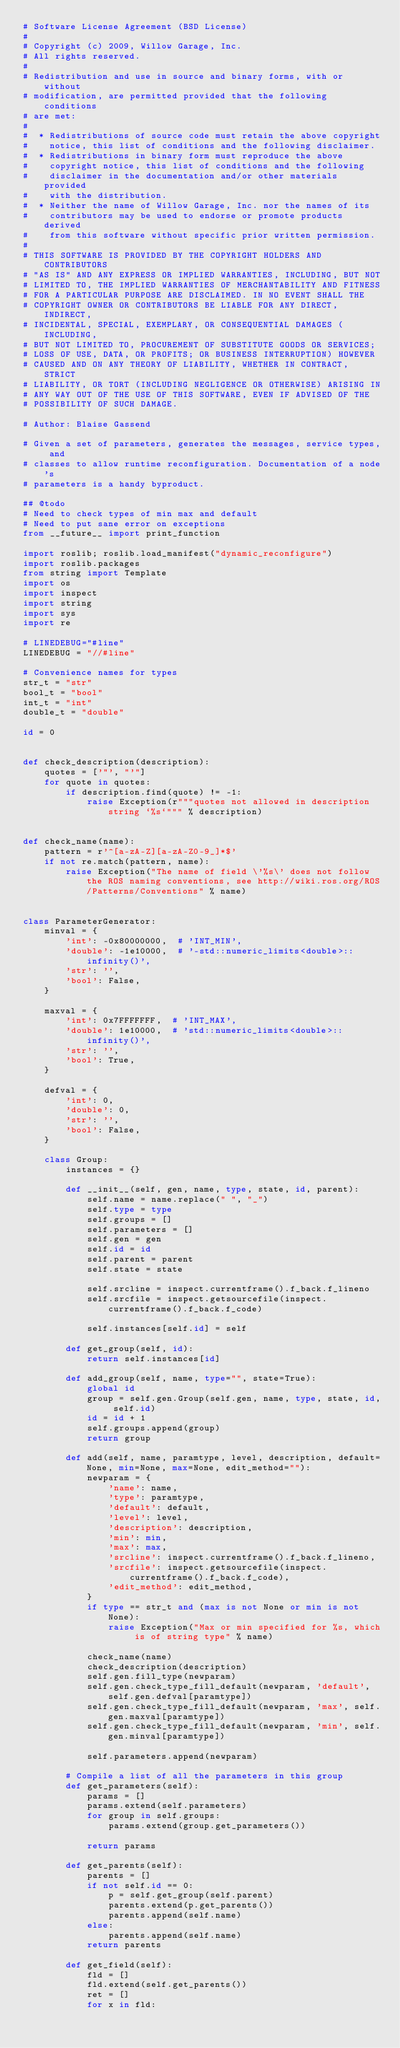<code> <loc_0><loc_0><loc_500><loc_500><_Python_># Software License Agreement (BSD License)
#
# Copyright (c) 2009, Willow Garage, Inc.
# All rights reserved.
#
# Redistribution and use in source and binary forms, with or without
# modification, are permitted provided that the following conditions
# are met:
#
#  * Redistributions of source code must retain the above copyright
#    notice, this list of conditions and the following disclaimer.
#  * Redistributions in binary form must reproduce the above
#    copyright notice, this list of conditions and the following
#    disclaimer in the documentation and/or other materials provided
#    with the distribution.
#  * Neither the name of Willow Garage, Inc. nor the names of its
#    contributors may be used to endorse or promote products derived
#    from this software without specific prior written permission.
#
# THIS SOFTWARE IS PROVIDED BY THE COPYRIGHT HOLDERS AND CONTRIBUTORS
# "AS IS" AND ANY EXPRESS OR IMPLIED WARRANTIES, INCLUDING, BUT NOT
# LIMITED TO, THE IMPLIED WARRANTIES OF MERCHANTABILITY AND FITNESS
# FOR A PARTICULAR PURPOSE ARE DISCLAIMED. IN NO EVENT SHALL THE
# COPYRIGHT OWNER OR CONTRIBUTORS BE LIABLE FOR ANY DIRECT, INDIRECT,
# INCIDENTAL, SPECIAL, EXEMPLARY, OR CONSEQUENTIAL DAMAGES (INCLUDING,
# BUT NOT LIMITED TO, PROCUREMENT OF SUBSTITUTE GOODS OR SERVICES;
# LOSS OF USE, DATA, OR PROFITS; OR BUSINESS INTERRUPTION) HOWEVER
# CAUSED AND ON ANY THEORY OF LIABILITY, WHETHER IN CONTRACT, STRICT
# LIABILITY, OR TORT (INCLUDING NEGLIGENCE OR OTHERWISE) ARISING IN
# ANY WAY OUT OF THE USE OF THIS SOFTWARE, EVEN IF ADVISED OF THE
# POSSIBILITY OF SUCH DAMAGE.

# Author: Blaise Gassend

# Given a set of parameters, generates the messages, service types, and
# classes to allow runtime reconfiguration. Documentation of a node's
# parameters is a handy byproduct.

## @todo
# Need to check types of min max and default
# Need to put sane error on exceptions
from __future__ import print_function

import roslib; roslib.load_manifest("dynamic_reconfigure")
import roslib.packages
from string import Template
import os
import inspect
import string
import sys
import re

# LINEDEBUG="#line"
LINEDEBUG = "//#line"

# Convenience names for types
str_t = "str"
bool_t = "bool"
int_t = "int"
double_t = "double"

id = 0


def check_description(description):
    quotes = ['"', "'"]
    for quote in quotes:
        if description.find(quote) != -1:
            raise Exception(r"""quotes not allowed in description string `%s`""" % description)


def check_name(name):
    pattern = r'^[a-zA-Z][a-zA-Z0-9_]*$'
    if not re.match(pattern, name):
        raise Exception("The name of field \'%s\' does not follow the ROS naming conventions, see http://wiki.ros.org/ROS/Patterns/Conventions" % name)


class ParameterGenerator:
    minval = {
        'int': -0x80000000,  # 'INT_MIN',
        'double': -1e10000,  # '-std::numeric_limits<double>::infinity()',
        'str': '',
        'bool': False,
    }

    maxval = {
        'int': 0x7FFFFFFF,  # 'INT_MAX',
        'double': 1e10000,  # 'std::numeric_limits<double>::infinity()',
        'str': '',
        'bool': True,
    }

    defval = {
        'int': 0,
        'double': 0,
        'str': '',
        'bool': False,
    }

    class Group:
        instances = {}

        def __init__(self, gen, name, type, state, id, parent):
            self.name = name.replace(" ", "_")
            self.type = type
            self.groups = []
            self.parameters = []
            self.gen = gen
            self.id = id
            self.parent = parent
            self.state = state

            self.srcline = inspect.currentframe().f_back.f_lineno
            self.srcfile = inspect.getsourcefile(inspect.currentframe().f_back.f_code)

            self.instances[self.id] = self

        def get_group(self, id):
            return self.instances[id]

        def add_group(self, name, type="", state=True):
            global id
            group = self.gen.Group(self.gen, name, type, state, id, self.id)
            id = id + 1
            self.groups.append(group)
            return group

        def add(self, name, paramtype, level, description, default=None, min=None, max=None, edit_method=""):
            newparam = {
                'name': name,
                'type': paramtype,
                'default': default,
                'level': level,
                'description': description,
                'min': min,
                'max': max,
                'srcline': inspect.currentframe().f_back.f_lineno,
                'srcfile': inspect.getsourcefile(inspect.currentframe().f_back.f_code),
                'edit_method': edit_method,
            }
            if type == str_t and (max is not None or min is not None):
                raise Exception("Max or min specified for %s, which is of string type" % name)

            check_name(name)
            check_description(description)
            self.gen.fill_type(newparam)
            self.gen.check_type_fill_default(newparam, 'default', self.gen.defval[paramtype])
            self.gen.check_type_fill_default(newparam, 'max', self.gen.maxval[paramtype])
            self.gen.check_type_fill_default(newparam, 'min', self.gen.minval[paramtype])

            self.parameters.append(newparam)

        # Compile a list of all the parameters in this group
        def get_parameters(self):
            params = []
            params.extend(self.parameters)
            for group in self.groups:
                params.extend(group.get_parameters())

            return params

        def get_parents(self):
            parents = []
            if not self.id == 0:
                p = self.get_group(self.parent)
                parents.extend(p.get_parents())
                parents.append(self.name)
            else:
                parents.append(self.name)
            return parents

        def get_field(self):
            fld = []
            fld.extend(self.get_parents())
            ret = []
            for x in fld:</code> 